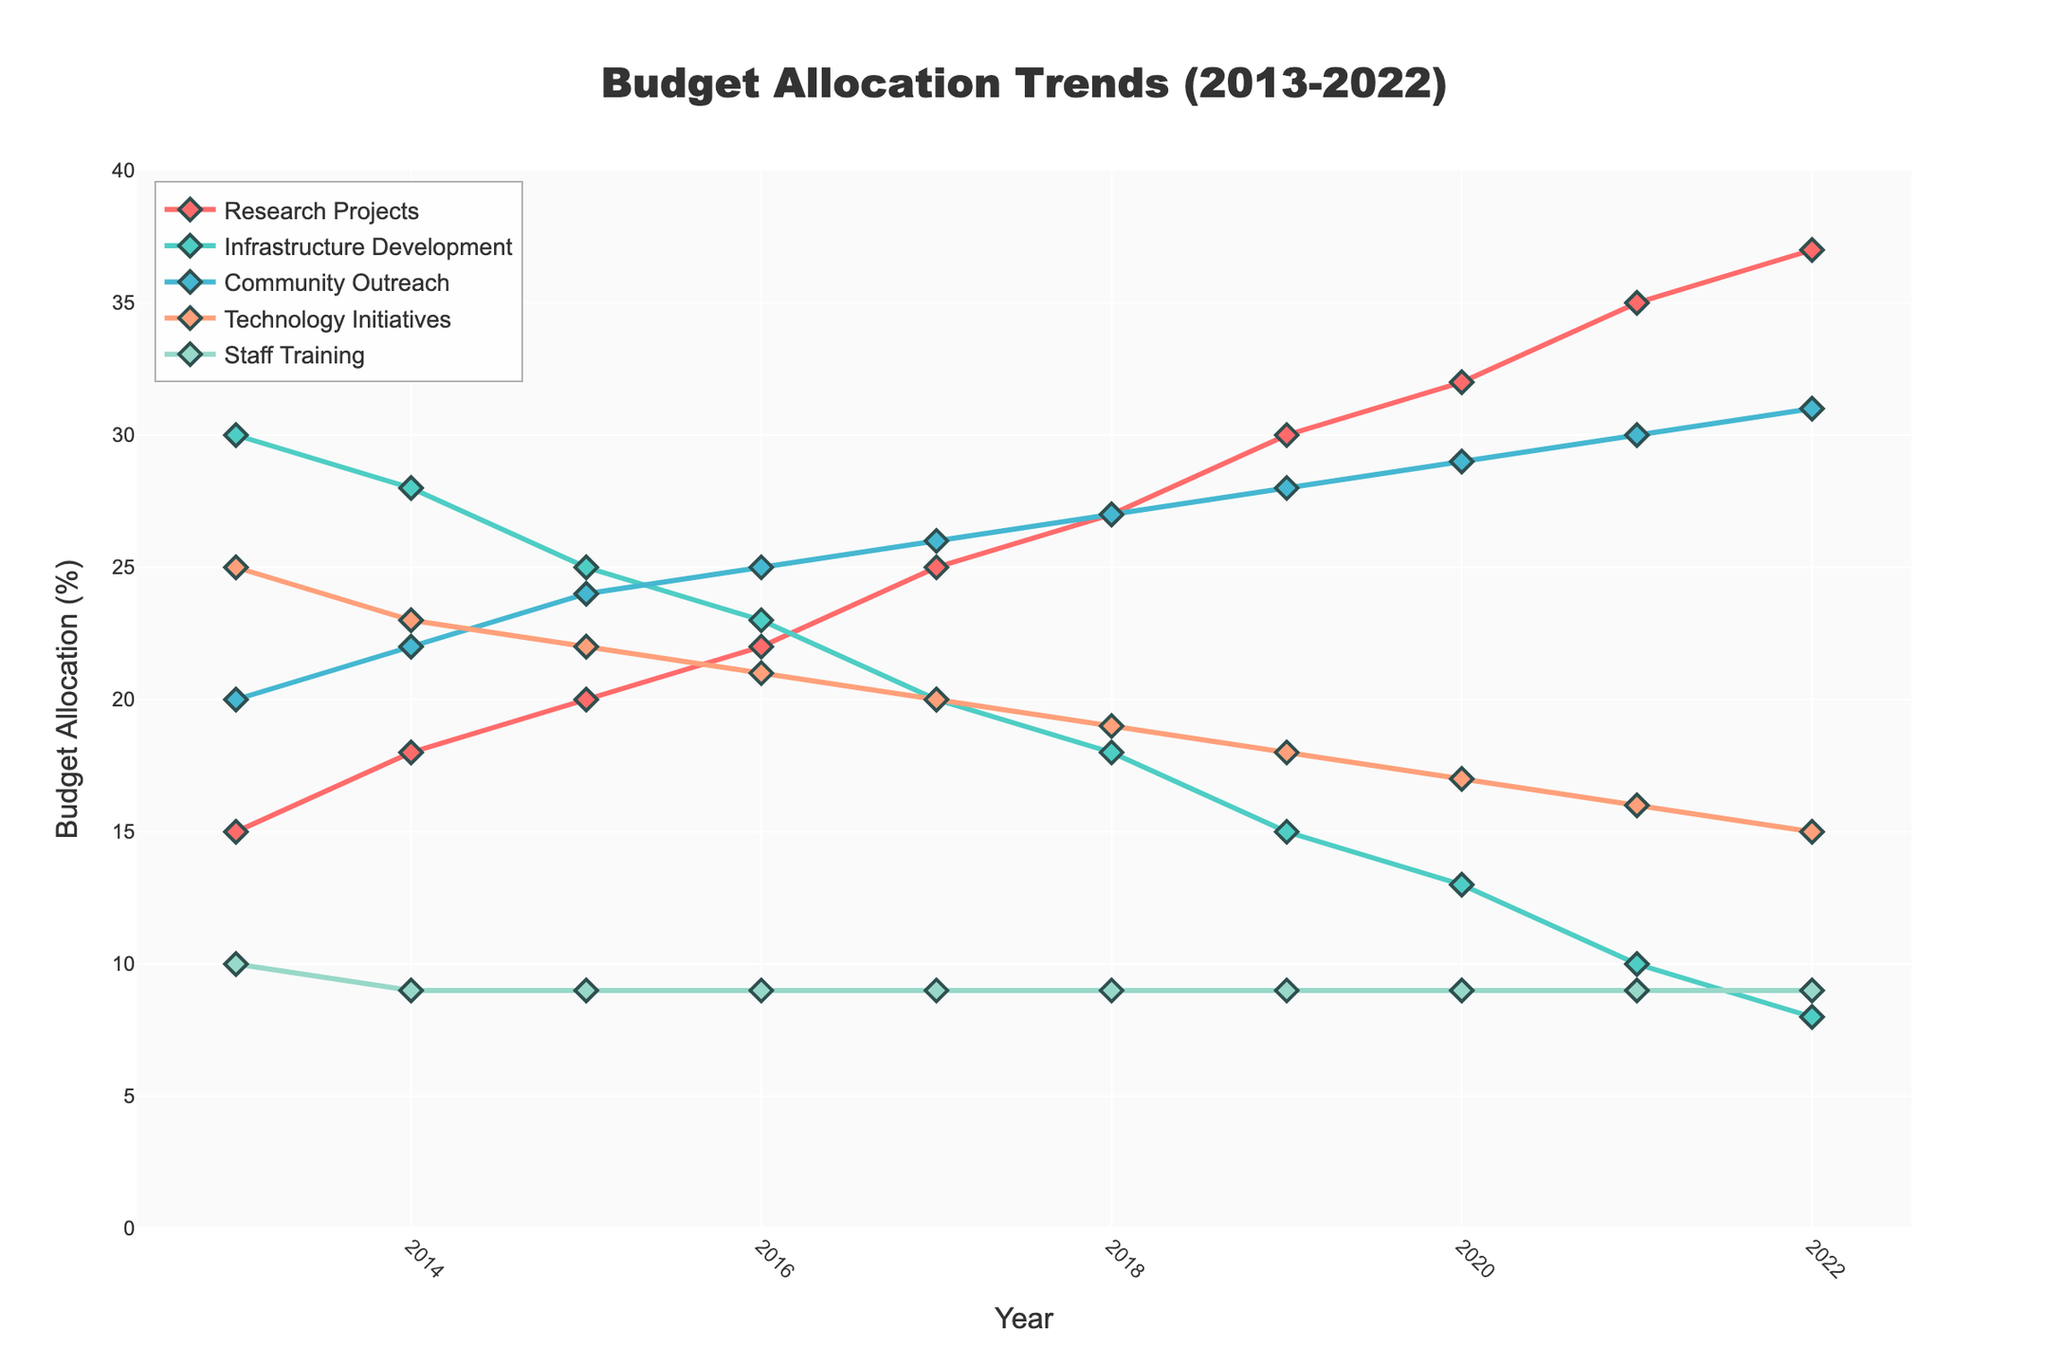What's the most significant trend observed in the budget allocation for Research Projects from 2013 to 2022? The budget allocation for Research Projects shows a consistent upward trend from 2013 (15%) to 2022 (37%). Each year, the percentage allocated to Research Projects increases.
Answer: Consistent upward trend Which project category experienced the largest decrease in budget allocation over the decade? The Infrastructure Development category has the largest decrease in budget allocation, starting from 30% in 2013 to 8% in 2022. The difference is calculated as 30% - 8% = 22%.
Answer: Infrastructure Development In what year did the Community Outreach budget allocation surpass the Infrastructure Development budget allocation for the first time? In 2015, Community Outreach (24%) surpassed Infrastructure Development (25%) because from 2016 onwards, Community Outreach consistently has higher values compared to Infrastructure Development.
Answer: 2015 What is the average budget allocation for Technology Initiatives from 2013 to 2022? Calculate the sum of Technology Initiatives (25+23+22+21+20+19+18+17+16+15 = 196) and divide by 10 years: 196/10 = 19.6
Answer: 19.6% Compare the budget allocations for Staff Training and Technology Initiatives in 2022. What do you observe? In 2022, Staff Training is consistently allocated 9%, while Technology Initiatives have decreased to 15%. Staff Training remains unchanged, while Technology Initiatives decrease over time.
Answer: Staff Training remains unchanged; Technology Initiatives decrease Between which years did the Research Projects category see the highest increase in budget allocation? The highest increase is between 2020 (32%) and 2021 (35%), which is a 3 percentage points increase.
Answer: 2020 to 2021 Calculate the total combined budget allocation for Community Outreach and Infrastructure Development in 2017. Community Outreach (26%) + Infrastructure Development (20%) = 46% in 2017.
Answer: 46% What is the trend for Staff Training's budget allocation over the entire decade? The budget allocation for Staff Training remains constant at 9% every year from 2014 to 2022.
Answer: Remains constant How does the average budget allocation for Infrastructure Development compare to that for Community Outreach over the decade? Average for Infrastructure Development: (30+28+25+23+20+18+15+13+10+8)/10 = 19.0%. Average for Community Outreach: (20+22+24+25+26+27+28+29+30+31)/10 = 26.2%. Clearly, Community Outreach has a higher average.
Answer: Community Outreach average is higher Based on the visual attributes, which project category is represented by the red line, and what can be inferred about its budget trend? The red line represents Research Projects. The budget allocation for this category shows a consistent upward trend from 2013 to 2022.
Answer: Research Projects; consistent upward trend 